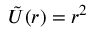Convert formula to latex. <formula><loc_0><loc_0><loc_500><loc_500>\tilde { U } ( r ) = r ^ { 2 }</formula> 